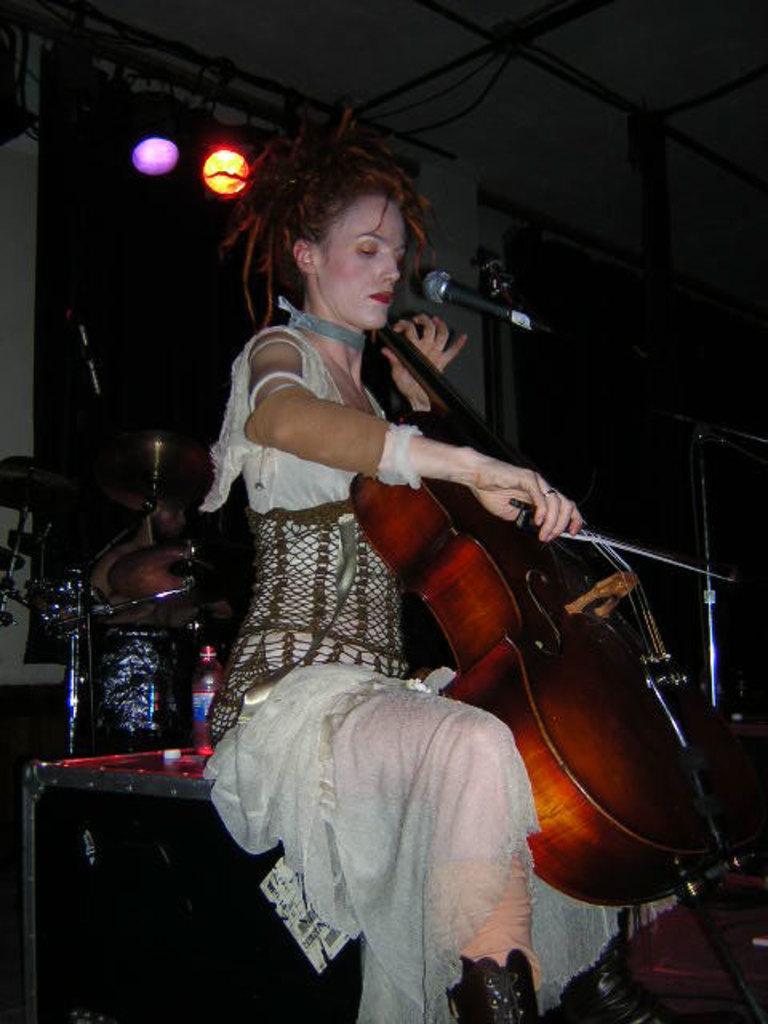Describe this image in one or two sentences. In this picture there is a woman who is wearing white dress. She is playing a guitar, beside her there is a mic. She is a sitting on the box, beside the box there is a chair. In the background we can see the window and wall. On the right we can see some objects on the table. At the top we can see the tables which is hanging from the roof. 